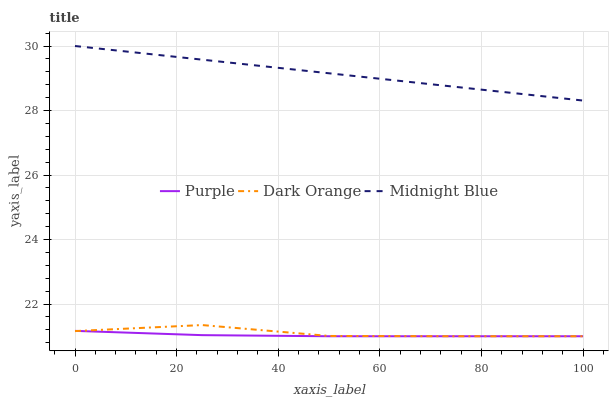Does Dark Orange have the minimum area under the curve?
Answer yes or no. No. Does Dark Orange have the maximum area under the curve?
Answer yes or no. No. Is Dark Orange the smoothest?
Answer yes or no. No. Is Midnight Blue the roughest?
Answer yes or no. No. Does Midnight Blue have the lowest value?
Answer yes or no. No. Does Dark Orange have the highest value?
Answer yes or no. No. Is Dark Orange less than Midnight Blue?
Answer yes or no. Yes. Is Midnight Blue greater than Dark Orange?
Answer yes or no. Yes. Does Dark Orange intersect Midnight Blue?
Answer yes or no. No. 